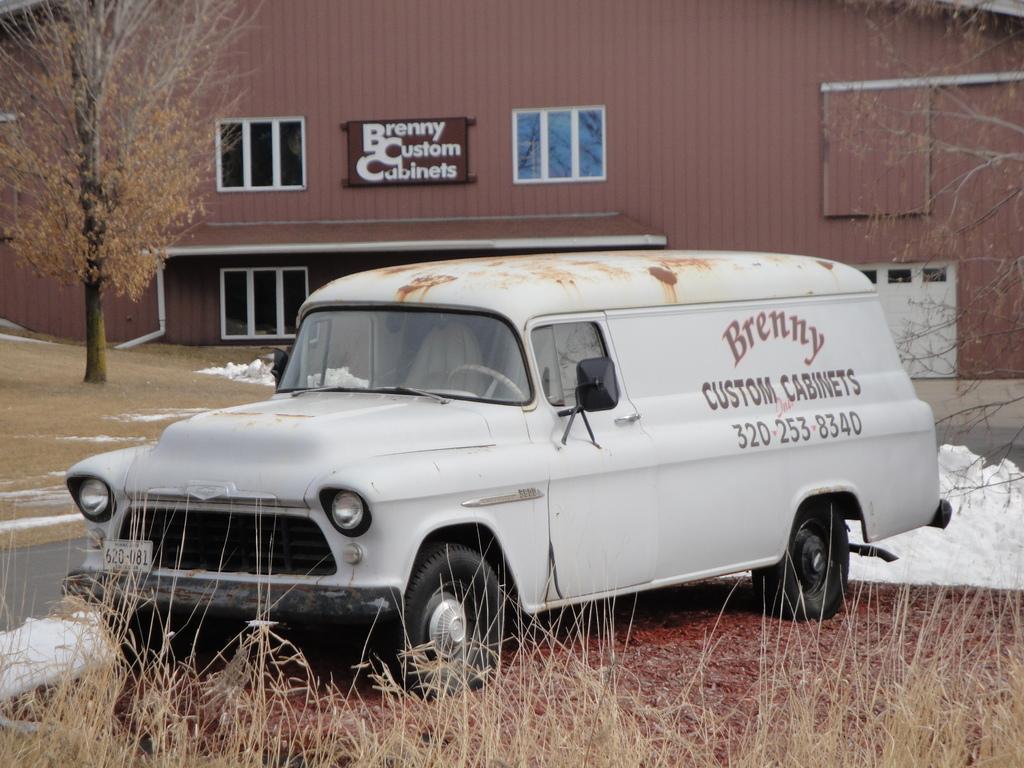Describe this image in one or two sentences. Here we can see vehicle and dried grass. Background we can see shed, windows, board and trees. 